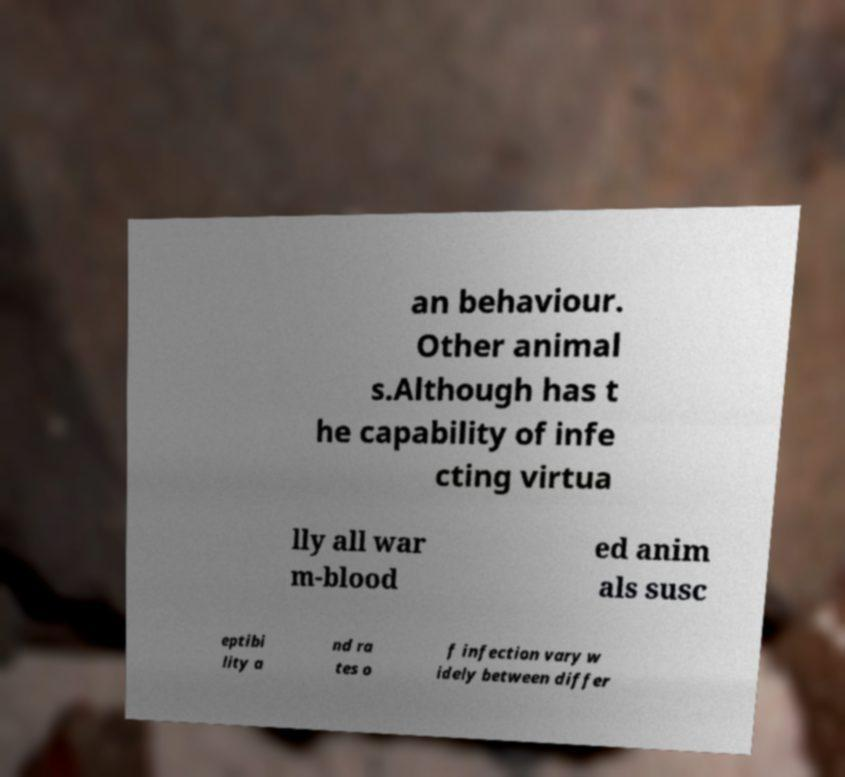Please identify and transcribe the text found in this image. an behaviour. Other animal s.Although has t he capability of infe cting virtua lly all war m-blood ed anim als susc eptibi lity a nd ra tes o f infection vary w idely between differ 